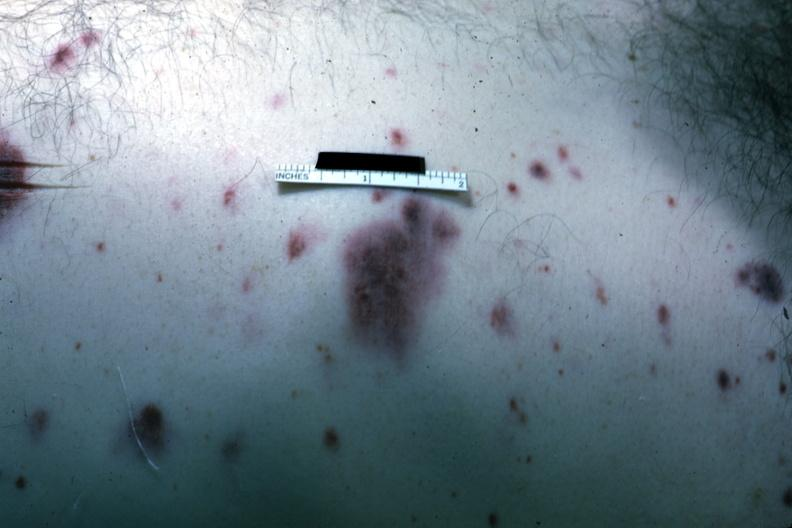where is this?
Answer the question using a single word or phrase. Skin 